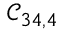<formula> <loc_0><loc_0><loc_500><loc_500>\mathcal { C } _ { 3 4 , 4 }</formula> 